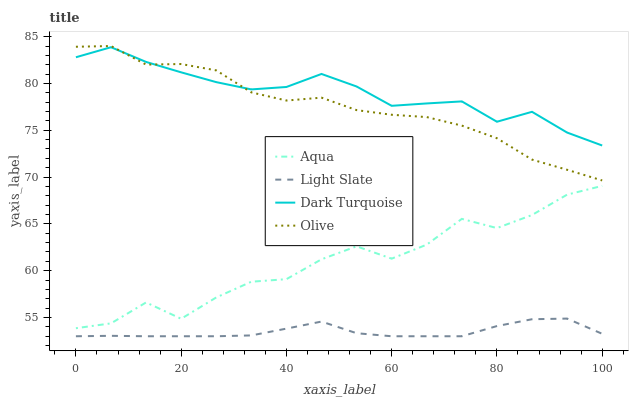Does Light Slate have the minimum area under the curve?
Answer yes or no. Yes. Does Dark Turquoise have the maximum area under the curve?
Answer yes or no. Yes. Does Aqua have the minimum area under the curve?
Answer yes or no. No. Does Aqua have the maximum area under the curve?
Answer yes or no. No. Is Light Slate the smoothest?
Answer yes or no. Yes. Is Aqua the roughest?
Answer yes or no. Yes. Is Dark Turquoise the smoothest?
Answer yes or no. No. Is Dark Turquoise the roughest?
Answer yes or no. No. Does Aqua have the lowest value?
Answer yes or no. No. Does Olive have the highest value?
Answer yes or no. Yes. Does Dark Turquoise have the highest value?
Answer yes or no. No. Is Light Slate less than Aqua?
Answer yes or no. Yes. Is Olive greater than Aqua?
Answer yes or no. Yes. Does Olive intersect Dark Turquoise?
Answer yes or no. Yes. Is Olive less than Dark Turquoise?
Answer yes or no. No. Is Olive greater than Dark Turquoise?
Answer yes or no. No. Does Light Slate intersect Aqua?
Answer yes or no. No. 